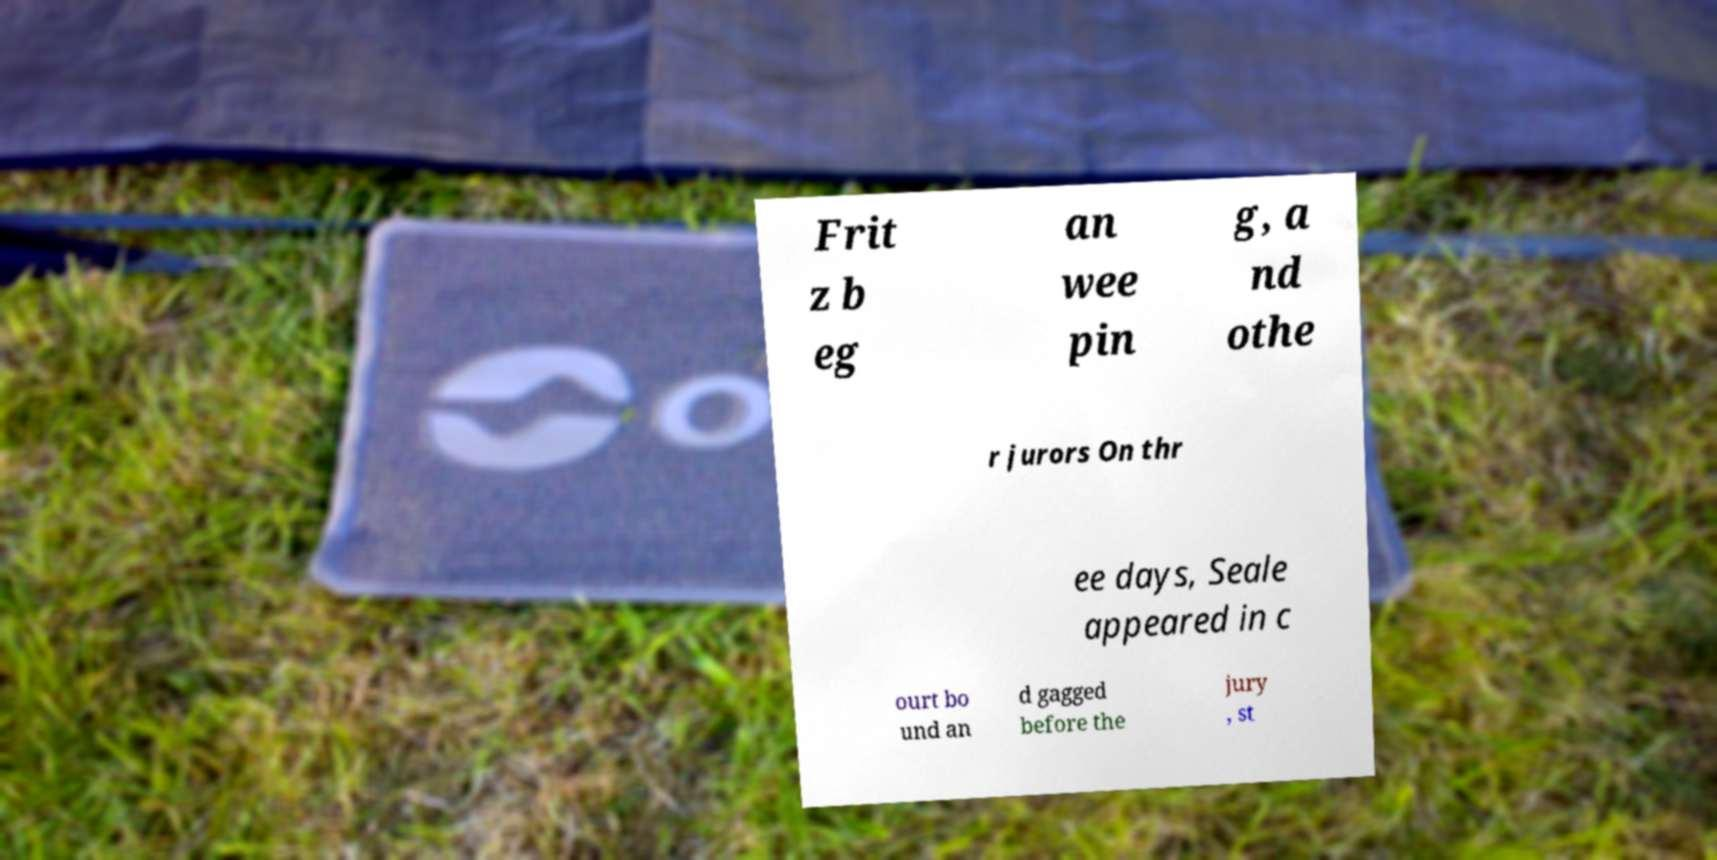Could you assist in decoding the text presented in this image and type it out clearly? Frit z b eg an wee pin g, a nd othe r jurors On thr ee days, Seale appeared in c ourt bo und an d gagged before the jury , st 